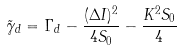Convert formula to latex. <formula><loc_0><loc_0><loc_500><loc_500>\tilde { \gamma } _ { d } = \Gamma _ { d } - \frac { ( \Delta I ) ^ { 2 } } { 4 S _ { 0 } } - \frac { K ^ { 2 } S _ { 0 } } { 4 } \,</formula> 